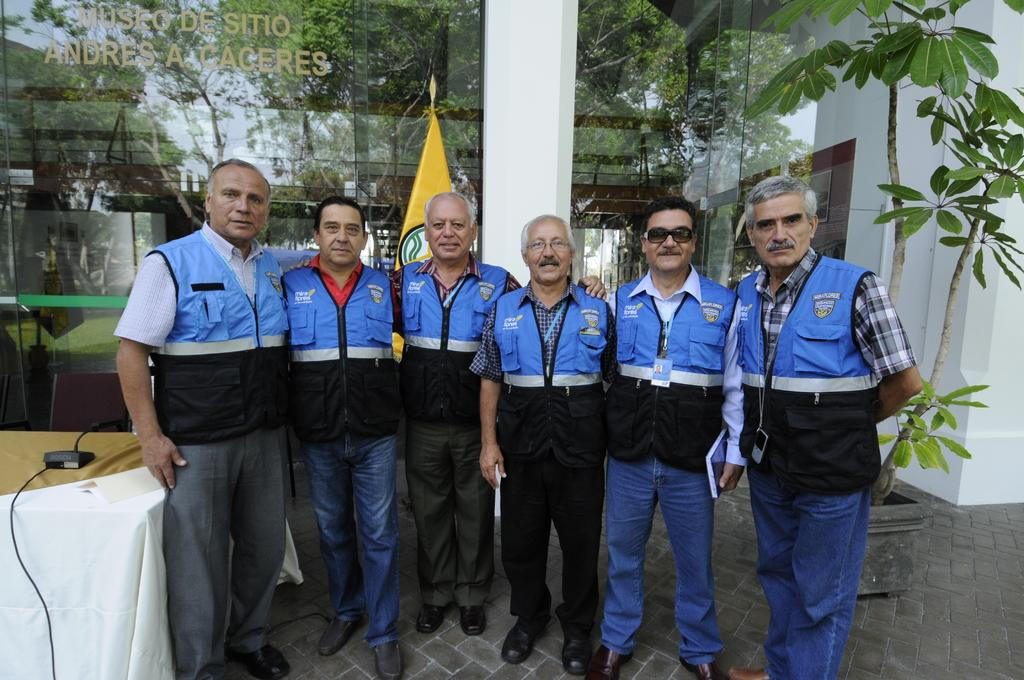What can be seen in the image regarding the people present? There is a group of men in the image. What are the men wearing on their feet? The men are wearing shoes. Where are the men standing? The men are standing on the floor. What type of vegetation is present in the image? There is a plant in the image. What piece of furniture can be seen in the image? There is a table in the image. What symbolic object is present in the image? There is a flag in the image. What type of object is used for a specific purpose in the image? There is a device in the image. Can you read any names or text in the image? There is a name on a glass in the background of the image. How many clovers are visible on the shoes of the men in the image? There are no clovers visible on the shoes of the men in the image. What type of shoe is the man wearing on his left foot? The provided facts do not specify the type of shoe the men are wearing, only that they are wearing shoes. 